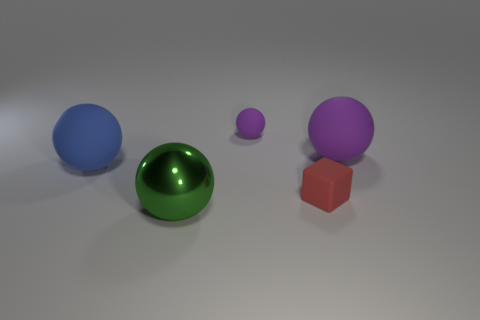Add 2 big shiny spheres. How many objects exist? 7 Subtract all large blue matte balls. How many balls are left? 3 Subtract 1 cubes. How many cubes are left? 0 Subtract all yellow cubes. Subtract all cyan spheres. How many cubes are left? 1 Subtract all purple cubes. How many green spheres are left? 1 Subtract all large green balls. Subtract all big green things. How many objects are left? 3 Add 2 rubber blocks. How many rubber blocks are left? 3 Add 1 rubber things. How many rubber things exist? 5 Subtract all green balls. How many balls are left? 3 Subtract 0 purple cylinders. How many objects are left? 5 